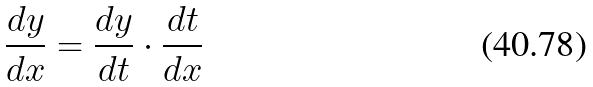Convert formula to latex. <formula><loc_0><loc_0><loc_500><loc_500>\frac { d y } { d x } = \frac { d y } { d t } \cdot \frac { d t } { d x }</formula> 